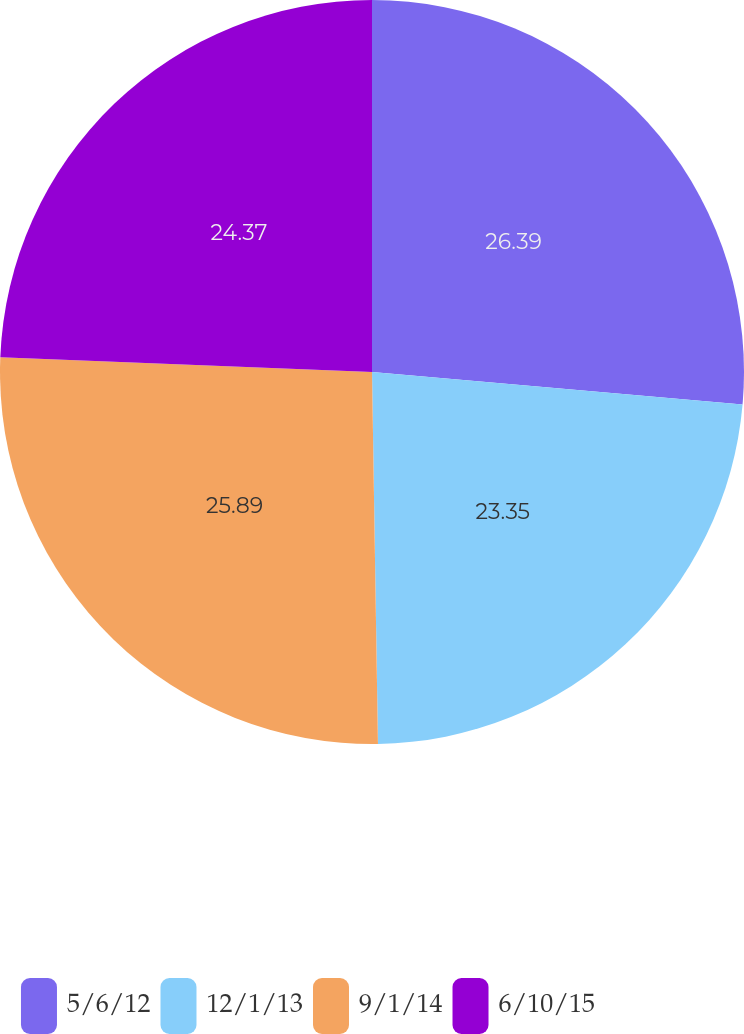Convert chart to OTSL. <chart><loc_0><loc_0><loc_500><loc_500><pie_chart><fcel>5/6/12<fcel>12/1/13<fcel>9/1/14<fcel>6/10/15<nl><fcel>26.4%<fcel>23.35%<fcel>25.89%<fcel>24.37%<nl></chart> 